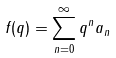Convert formula to latex. <formula><loc_0><loc_0><loc_500><loc_500>f ( q ) = \sum _ { n = 0 } ^ { \infty } q ^ { n } a _ { n }</formula> 